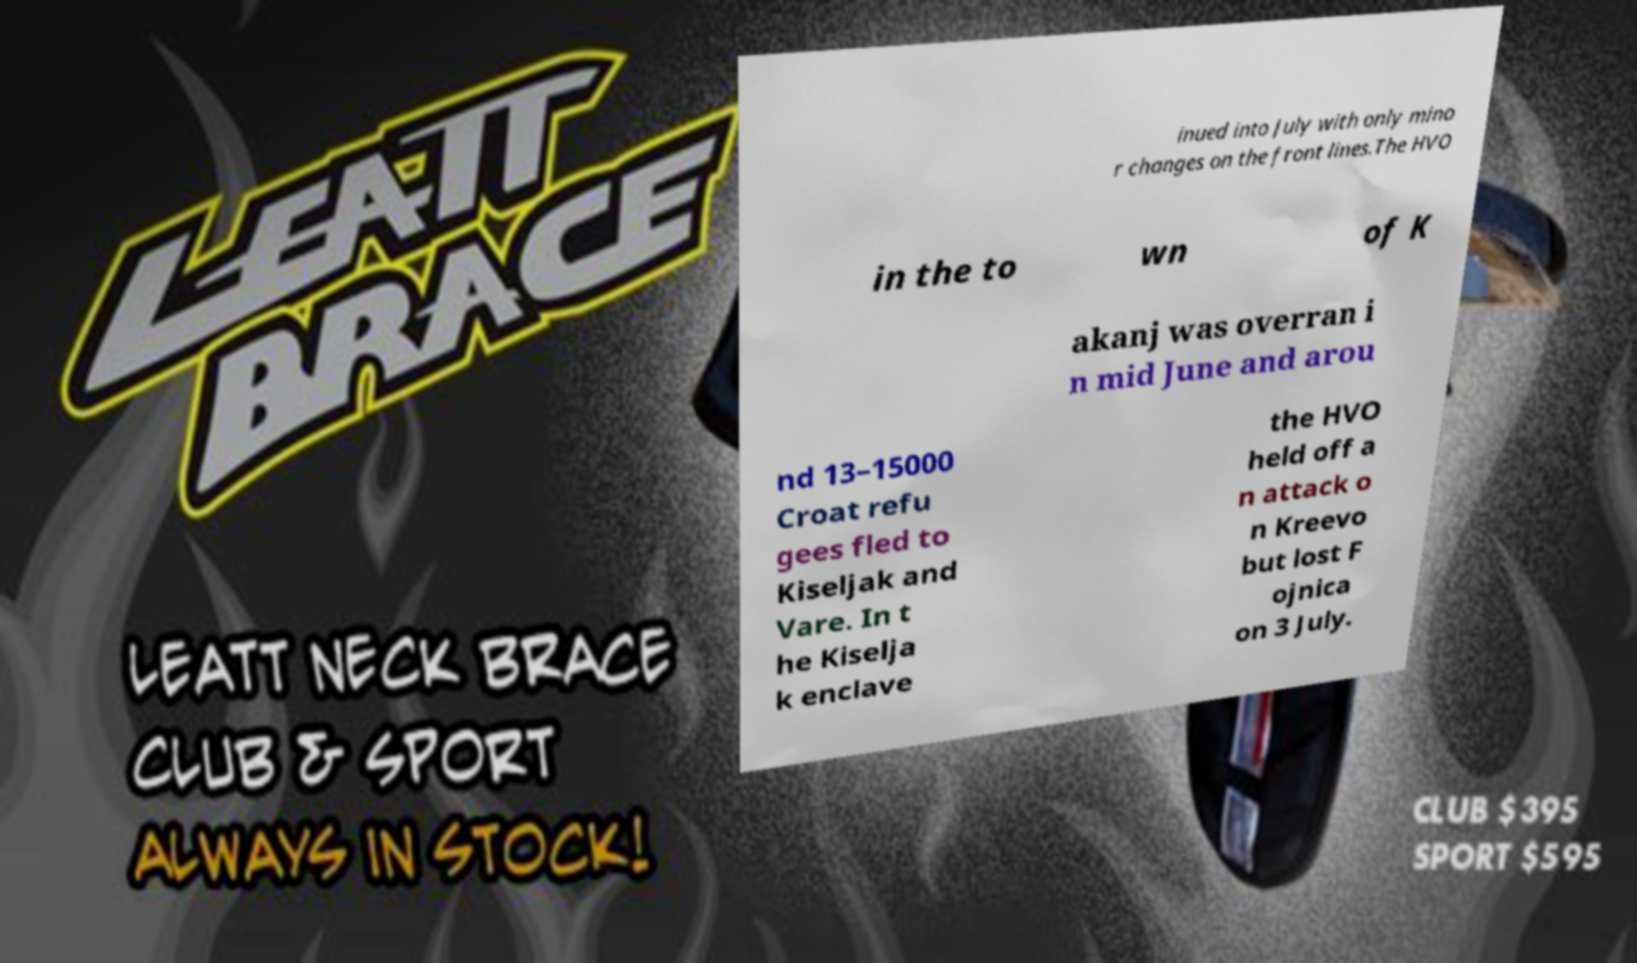Please read and relay the text visible in this image. What does it say? inued into July with only mino r changes on the front lines.The HVO in the to wn of K akanj was overran i n mid June and arou nd 13–15000 Croat refu gees fled to Kiseljak and Vare. In t he Kiselja k enclave the HVO held off a n attack o n Kreevo but lost F ojnica on 3 July. 